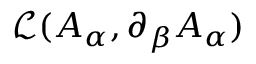Convert formula to latex. <formula><loc_0><loc_0><loc_500><loc_500>{ \mathcal { L } } ( A _ { \alpha } , \partial _ { \beta } A _ { \alpha } )</formula> 